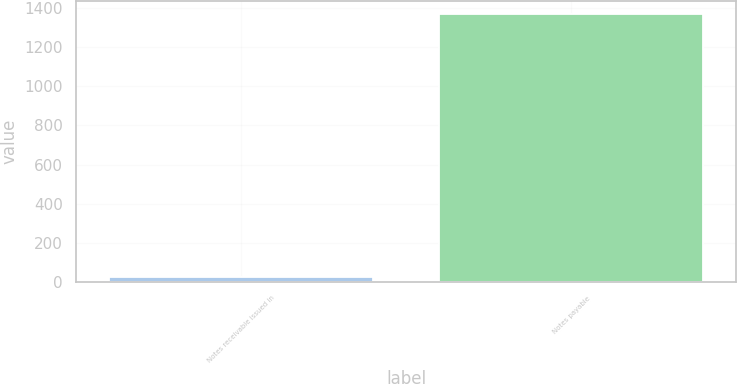Convert chart to OTSL. <chart><loc_0><loc_0><loc_500><loc_500><bar_chart><fcel>Notes receivable issued in<fcel>Notes payable<nl><fcel>22.3<fcel>1370<nl></chart> 